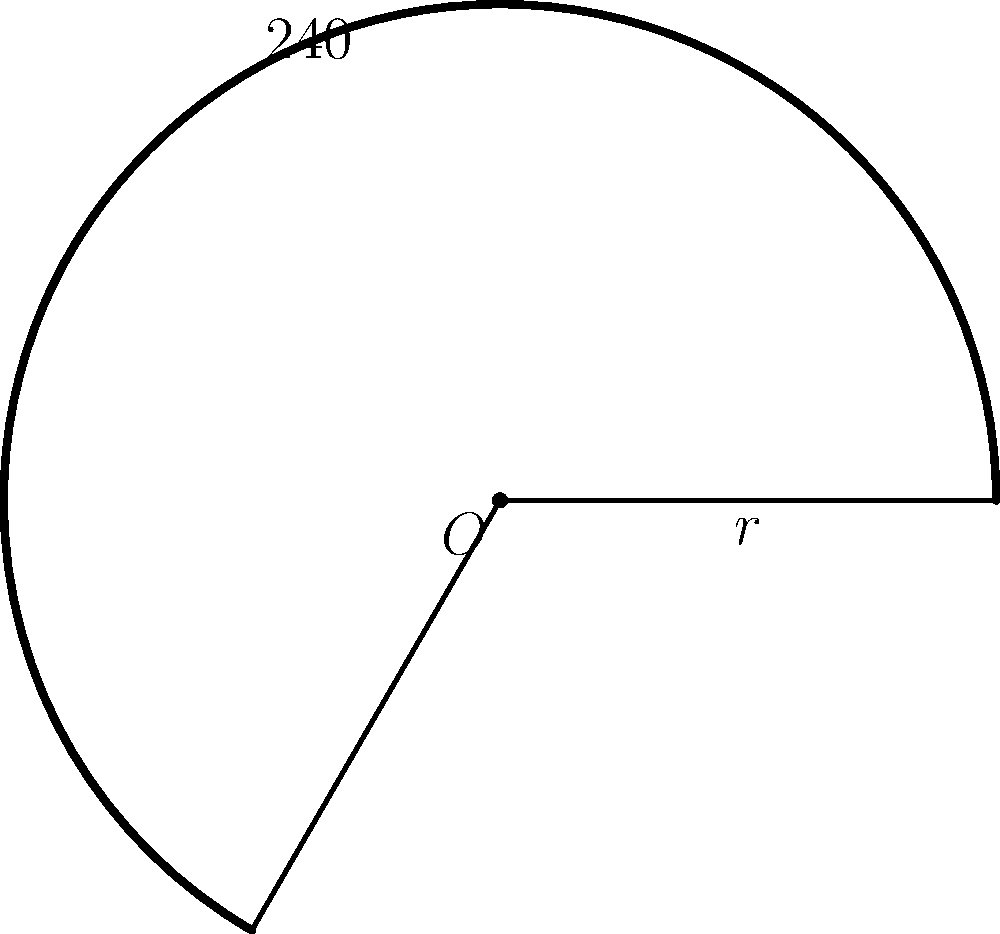During your time in South Korea, you learned about the traditional hanbok. The skirt part of a hanbok can be modeled as a circular sector. If the radius of the skirt is 80 cm and it forms an angle of 240°, what is the area of the skirt in square meters? Round your answer to two decimal places. To find the area of the circular sector representing the hanbok skirt, we'll follow these steps:

1) The formula for the area of a circular sector is:

   $$A = \frac{1}{2} r^2 \theta$$

   where $r$ is the radius and $\theta$ is the angle in radians.

2) We're given the radius $r = 80$ cm and the angle of 240°. We need to convert the angle to radians:

   $$\theta = 240° \times \frac{\pi}{180°} = \frac{4\pi}{3}$$ radians

3) Now we can substitute these values into our formula:

   $$A = \frac{1}{2} \times 80^2 \times \frac{4\pi}{3}$$

4) Simplify:

   $$A = \frac{25600\pi}{3}$$ sq cm

5) Convert to square meters:

   $$A = \frac{25600\pi}{3} \times \frac{1}{10000} = \frac{8\pi}{3}$$ sq m

6) Calculate and round to two decimal places:

   $$A \approx 8.38$$ sq m

Therefore, the area of the hanbok skirt is approximately 8.38 square meters.
Answer: 8.38 sq m 